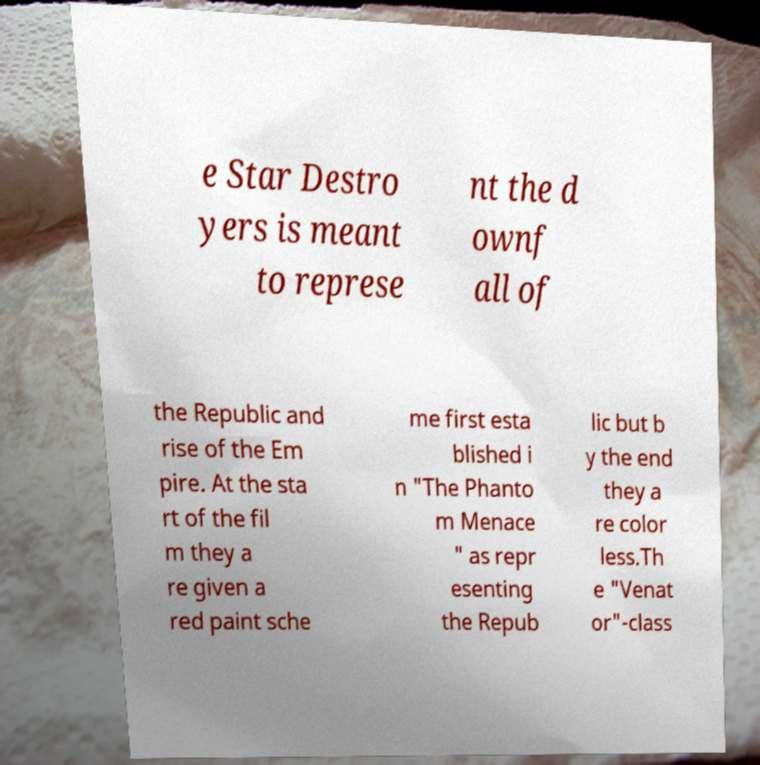Please identify and transcribe the text found in this image. e Star Destro yers is meant to represe nt the d ownf all of the Republic and rise of the Em pire. At the sta rt of the fil m they a re given a red paint sche me first esta blished i n "The Phanto m Menace " as repr esenting the Repub lic but b y the end they a re color less.Th e "Venat or"-class 